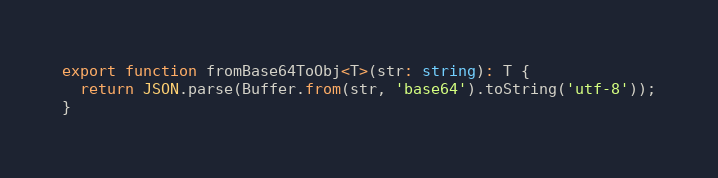Convert code to text. <code><loc_0><loc_0><loc_500><loc_500><_TypeScript_>export function fromBase64ToObj<T>(str: string): T {
  return JSON.parse(Buffer.from(str, 'base64').toString('utf-8'));
}
</code> 